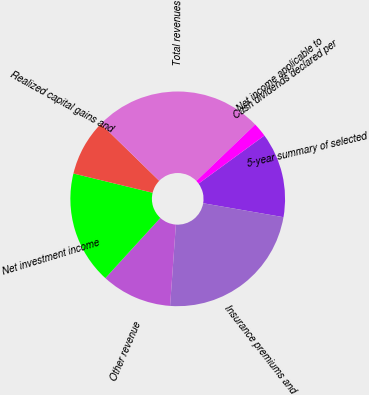Convert chart to OTSL. <chart><loc_0><loc_0><loc_500><loc_500><pie_chart><fcel>5-year summary of selected<fcel>Insurance premiums and<fcel>Other revenue<fcel>Net investment income<fcel>Realized capital gains and<fcel>Total revenues<fcel>Net income applicable to<fcel>Cash dividends declared per<nl><fcel>12.77%<fcel>23.4%<fcel>10.64%<fcel>17.02%<fcel>8.51%<fcel>25.53%<fcel>2.13%<fcel>0.0%<nl></chart> 